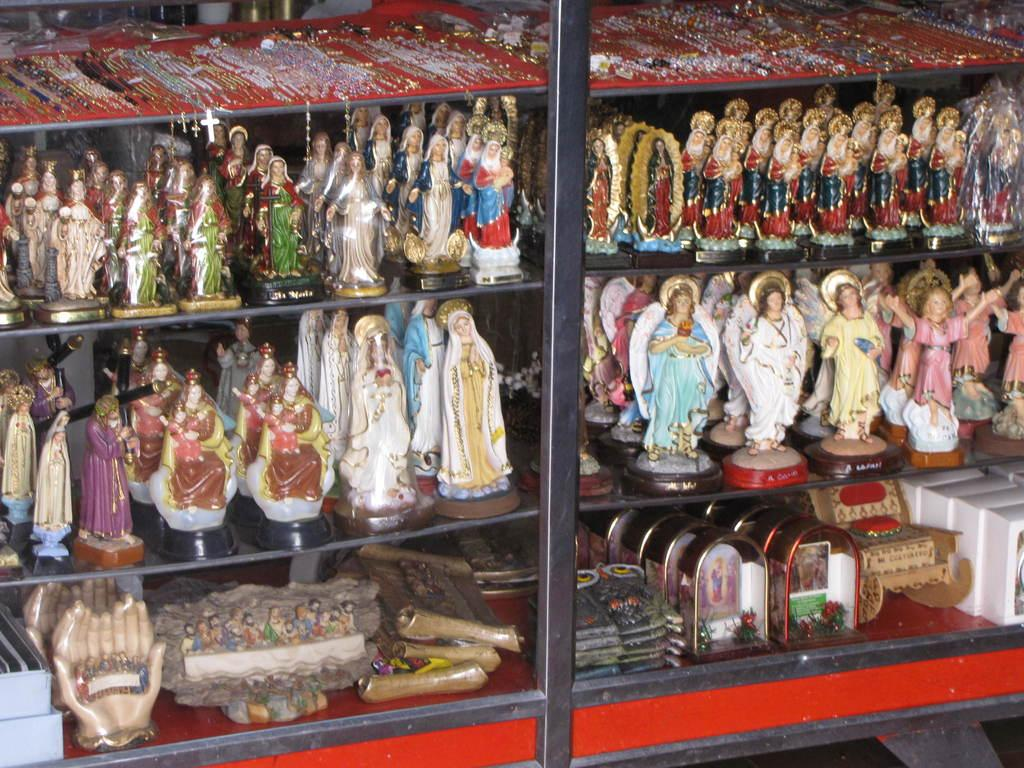What objects are in the image? There are dolls in the image. Where are the dolls located? The dolls are on a shelf. What type of carriage do the dolls use to travel in the image? There is no carriage present in the image; the dolls are on a shelf. What are the names of the dolls in the image? The names of the dolls are not mentioned in the image, so we cannot determine their names. 